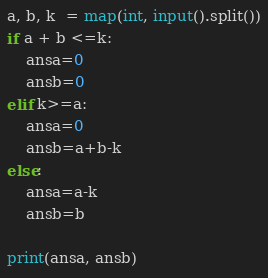<code> <loc_0><loc_0><loc_500><loc_500><_Python_>a, b, k  = map(int, input().split())
if a + b <=k:
    ansa=0
    ansb=0
elif k>=a:
    ansa=0
    ansb=a+b-k
else:
    ansa=a-k
    ansb=b

print(ansa, ansb)
</code> 